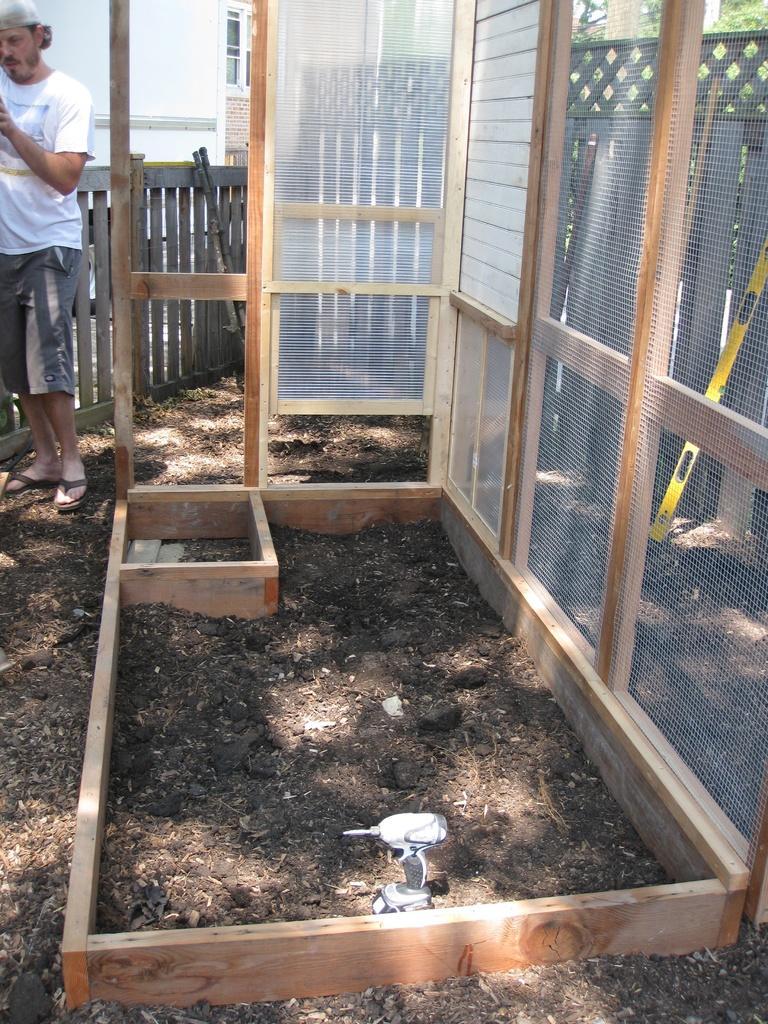Describe this image in one or two sentences. In this image, we can see a machine with a wooden stand. There is a drilling machine at the bottom of the image. There is a person in the top left of the image standing and wearing clothes. In the background, we can see a wooden fence. 